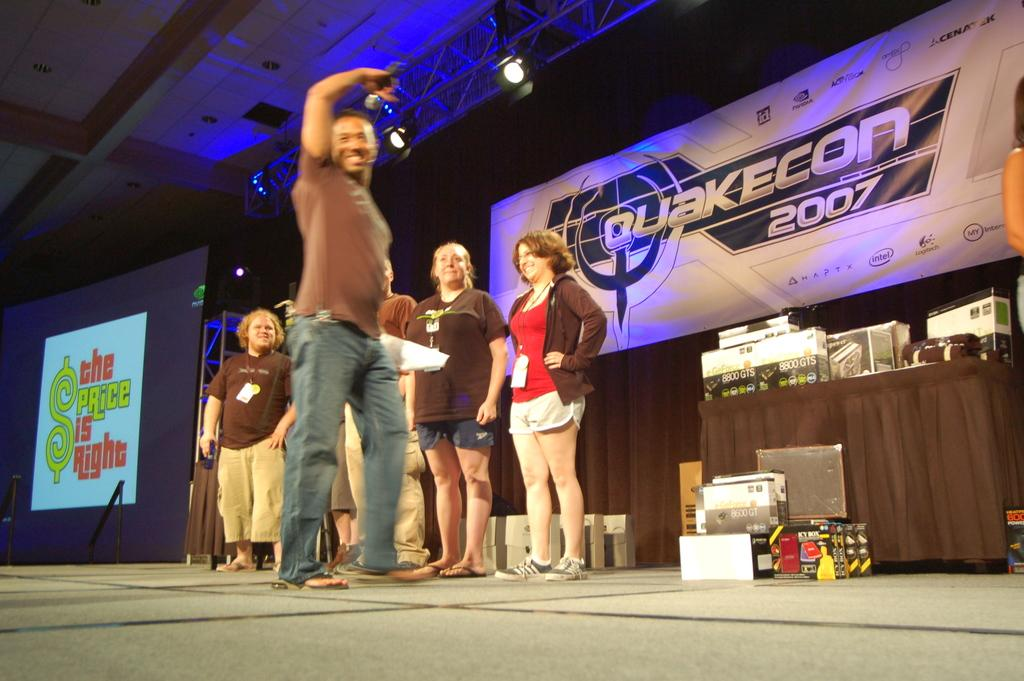What is present in the image involving people? There are people standing in the image. What can be seen on a surface in the image? There is a screen in the image. What other items can be observed in the image? There are various objects in the image. What is the source of illumination in the image? There is light visible in the image. What type of material is visible in the image? There is paper visible in the image. How does the cactus blow in the wind in the image? There is no cactus present in the image. What type of organization is depicted in the image? The image does not show any organization; it features people, a screen, various objects, light, and paper. 